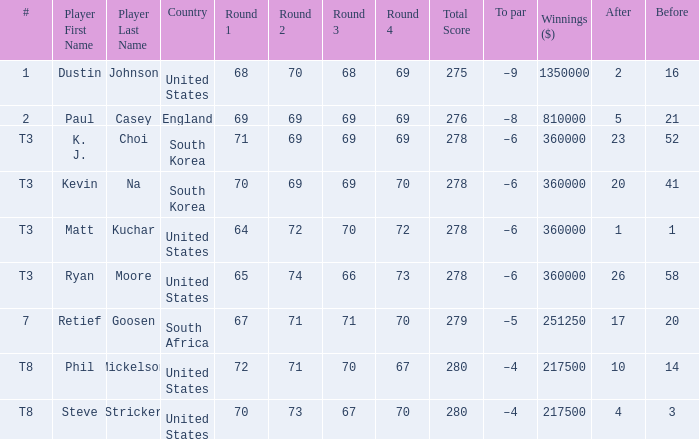What is the player listed when the score is 68-70-68-69=275 Dustin Johnson. 